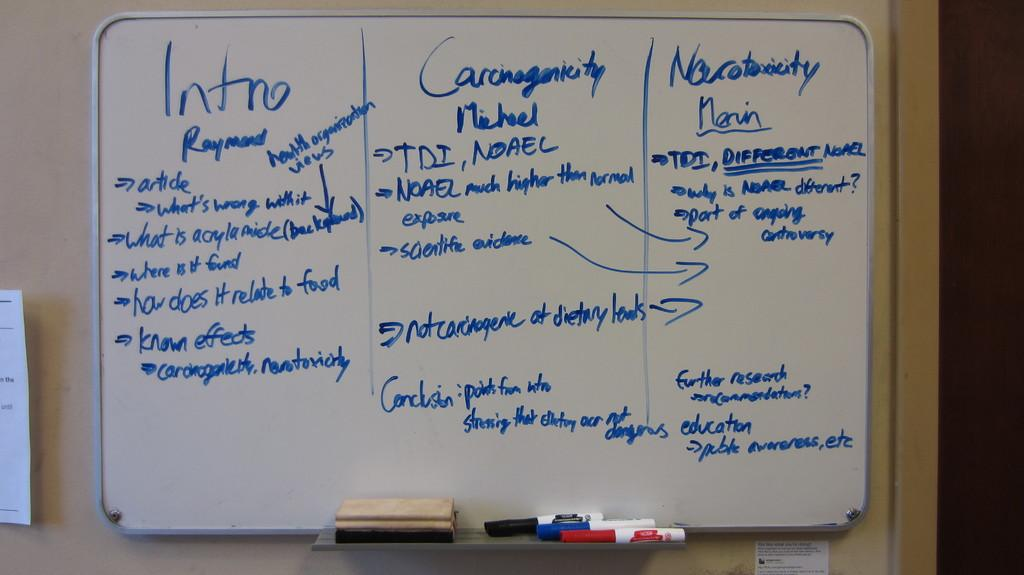Provide a one-sentence caption for the provided image. A dry erase board on a wall divided into 3 sections labeled Intro, and two others. 